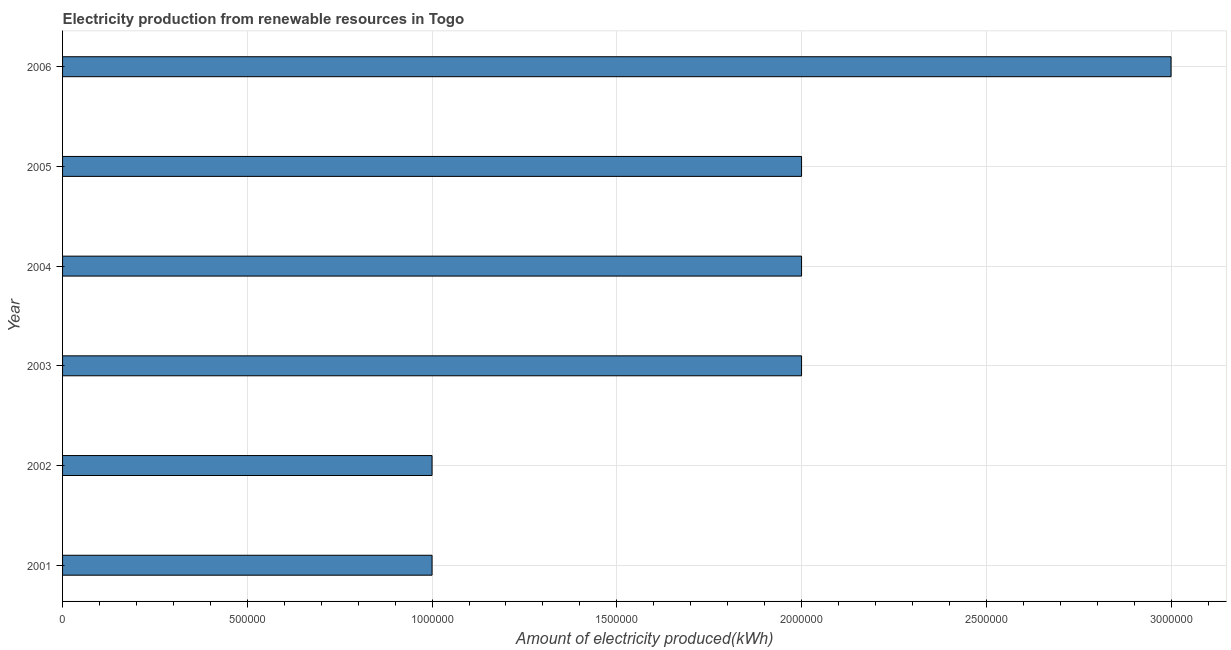Does the graph contain any zero values?
Provide a short and direct response. No. What is the title of the graph?
Keep it short and to the point. Electricity production from renewable resources in Togo. What is the label or title of the X-axis?
Your answer should be very brief. Amount of electricity produced(kWh). What is the label or title of the Y-axis?
Provide a succinct answer. Year. What is the sum of the amount of electricity produced?
Provide a short and direct response. 1.10e+07. What is the average amount of electricity produced per year?
Offer a terse response. 1.83e+06. What is the median amount of electricity produced?
Ensure brevity in your answer.  2.00e+06. In how many years, is the amount of electricity produced greater than 400000 kWh?
Provide a short and direct response. 6. What is the ratio of the amount of electricity produced in 2001 to that in 2004?
Keep it short and to the point. 0.5. Is the amount of electricity produced in 2001 less than that in 2005?
Provide a succinct answer. Yes. Is the sum of the amount of electricity produced in 2001 and 2005 greater than the maximum amount of electricity produced across all years?
Offer a very short reply. No. What is the difference between the highest and the lowest amount of electricity produced?
Offer a terse response. 2.00e+06. In how many years, is the amount of electricity produced greater than the average amount of electricity produced taken over all years?
Ensure brevity in your answer.  4. Are all the bars in the graph horizontal?
Your answer should be compact. Yes. How many years are there in the graph?
Offer a terse response. 6. Are the values on the major ticks of X-axis written in scientific E-notation?
Keep it short and to the point. No. What is the Amount of electricity produced(kWh) in 2001?
Your answer should be very brief. 1.00e+06. What is the Amount of electricity produced(kWh) in 2002?
Your response must be concise. 1.00e+06. What is the Amount of electricity produced(kWh) of 2003?
Your response must be concise. 2.00e+06. What is the Amount of electricity produced(kWh) in 2004?
Provide a short and direct response. 2.00e+06. What is the difference between the Amount of electricity produced(kWh) in 2001 and 2004?
Make the answer very short. -1.00e+06. What is the difference between the Amount of electricity produced(kWh) in 2001 and 2005?
Provide a short and direct response. -1.00e+06. What is the difference between the Amount of electricity produced(kWh) in 2002 and 2005?
Your answer should be very brief. -1.00e+06. What is the difference between the Amount of electricity produced(kWh) in 2003 and 2005?
Make the answer very short. 0. What is the difference between the Amount of electricity produced(kWh) in 2004 and 2005?
Offer a terse response. 0. What is the ratio of the Amount of electricity produced(kWh) in 2001 to that in 2003?
Provide a succinct answer. 0.5. What is the ratio of the Amount of electricity produced(kWh) in 2001 to that in 2004?
Keep it short and to the point. 0.5. What is the ratio of the Amount of electricity produced(kWh) in 2001 to that in 2006?
Provide a succinct answer. 0.33. What is the ratio of the Amount of electricity produced(kWh) in 2002 to that in 2003?
Offer a very short reply. 0.5. What is the ratio of the Amount of electricity produced(kWh) in 2002 to that in 2006?
Make the answer very short. 0.33. What is the ratio of the Amount of electricity produced(kWh) in 2003 to that in 2004?
Offer a terse response. 1. What is the ratio of the Amount of electricity produced(kWh) in 2003 to that in 2005?
Your answer should be very brief. 1. What is the ratio of the Amount of electricity produced(kWh) in 2003 to that in 2006?
Provide a succinct answer. 0.67. What is the ratio of the Amount of electricity produced(kWh) in 2004 to that in 2005?
Ensure brevity in your answer.  1. What is the ratio of the Amount of electricity produced(kWh) in 2004 to that in 2006?
Your answer should be very brief. 0.67. What is the ratio of the Amount of electricity produced(kWh) in 2005 to that in 2006?
Ensure brevity in your answer.  0.67. 